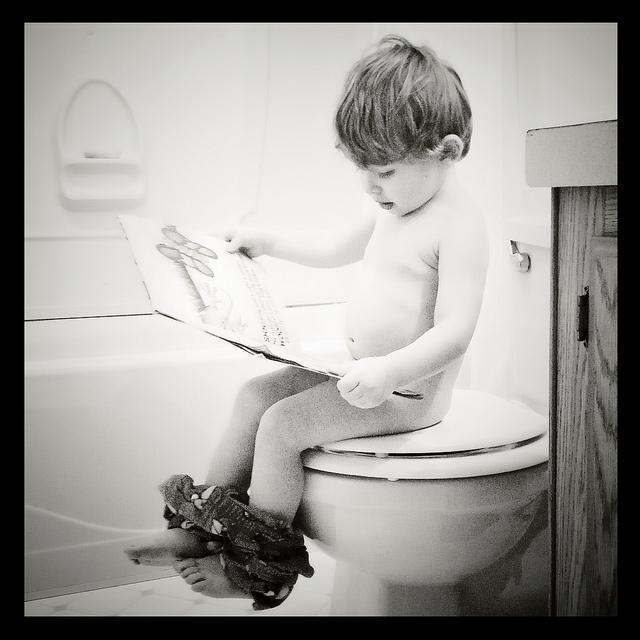What does the child do here?
Choose the correct response and explain in the format: 'Answer: answer
Rationale: rationale.'
Options: Brush teeth, number 1, number 2, read. Answer: read.
Rationale: He is sitting on a potty with his pants around his ankles. 